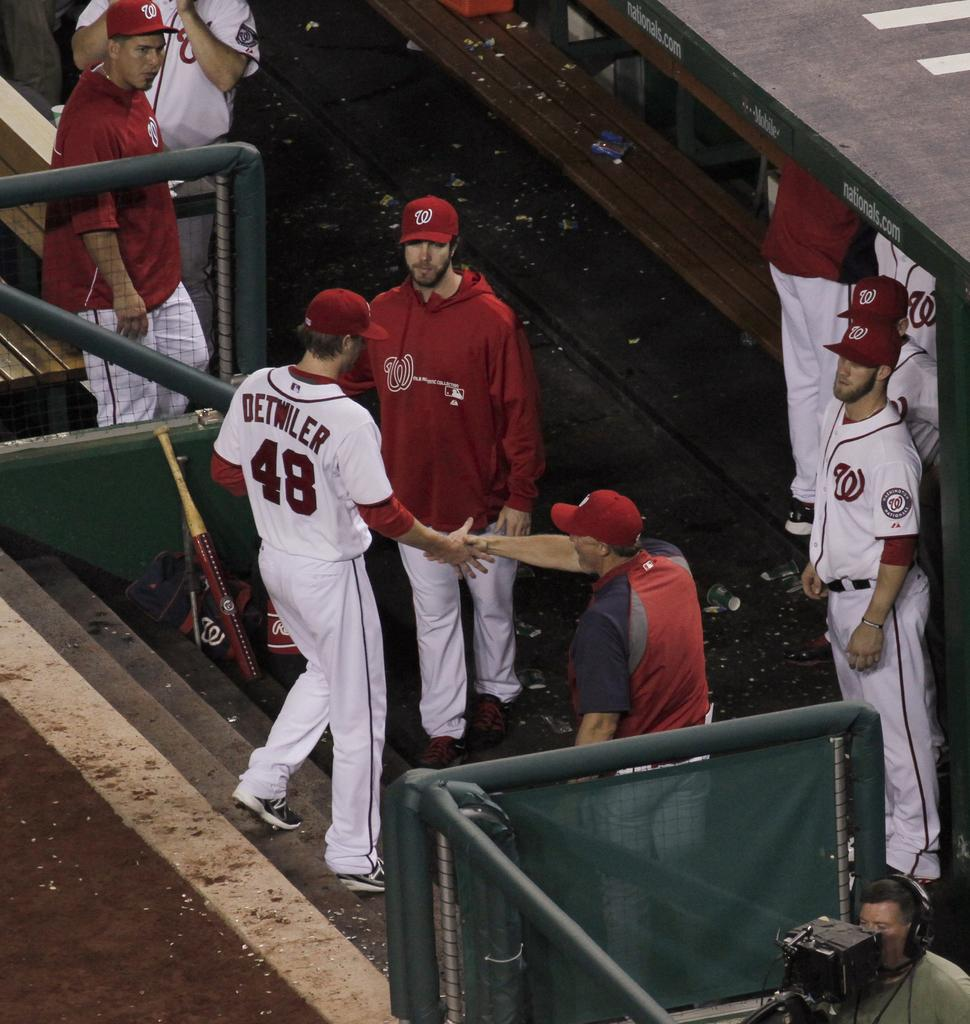<image>
Render a clear and concise summary of the photo. A baseball player named Detwiler wears a uniform with the number 48 on it. 